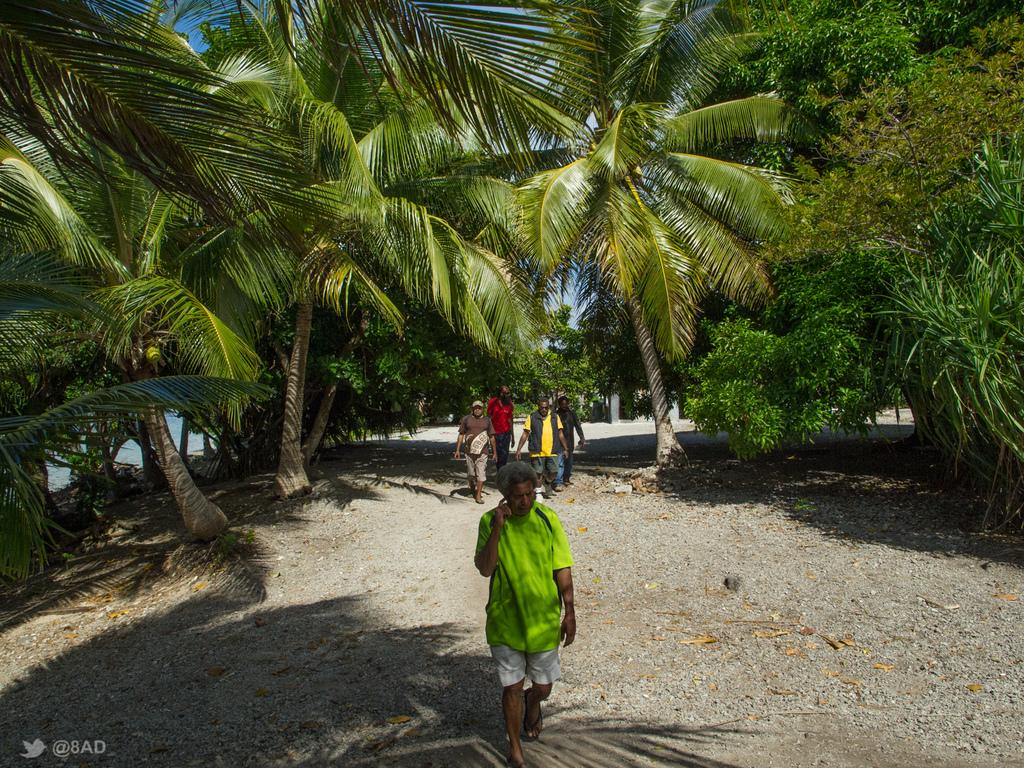What are the people in the image doing? The people in the image are walking. On what surface are the people walking? The people are walking on the ground. What can be seen in the background of the image? There are huge coconut trees in the background of the image. What type of zipper can be seen on the coconut trees in the image? There are no zippers present on the coconut trees in the image; they are natural trees. 